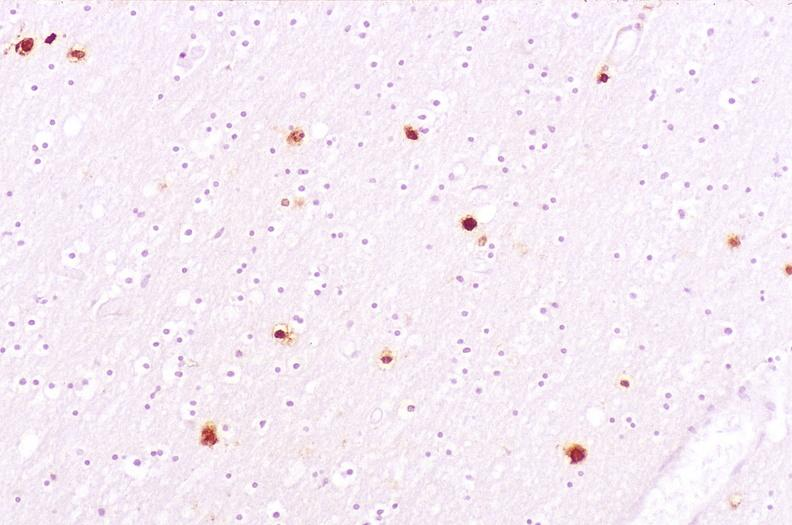what is present?
Answer the question using a single word or phrase. Nervous 